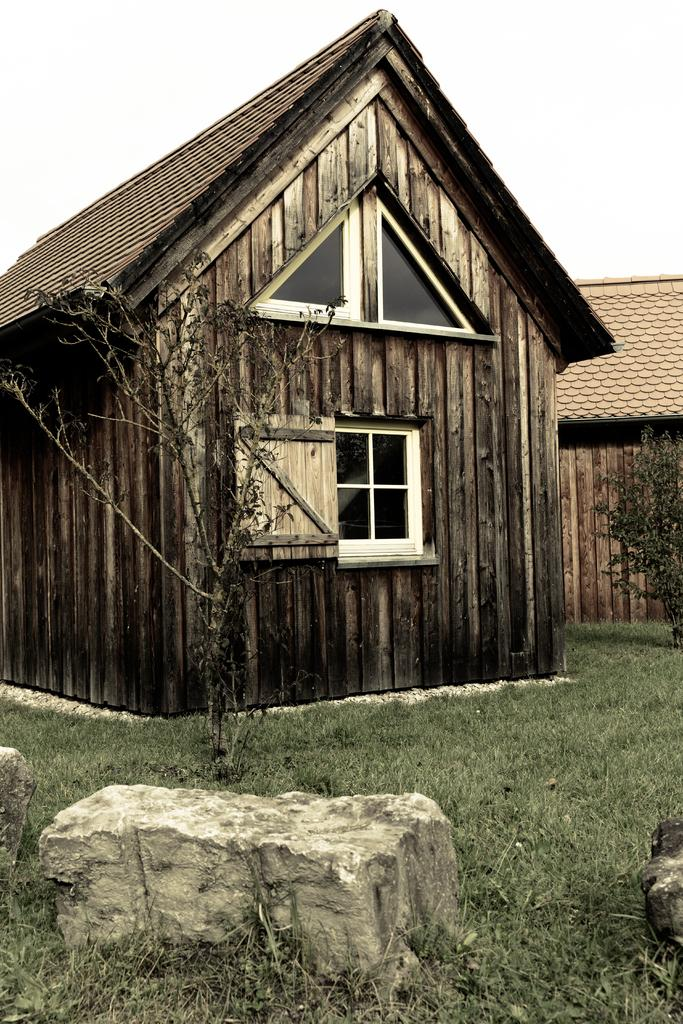How many wooden houses are in the image? There are two wooden houses in the image. What type of windows do the houses have? The houses have glass windows. What is the landscape in front of the houses? There is a grassy area in front of the houses. What can be found in the grassy area? Plants are present in the grassy area. Where is the crowd gathered in the image? There is no crowd present in the image. Which actor is performing in front of the houses in the image? There are no actors or performances depicted in the image. 